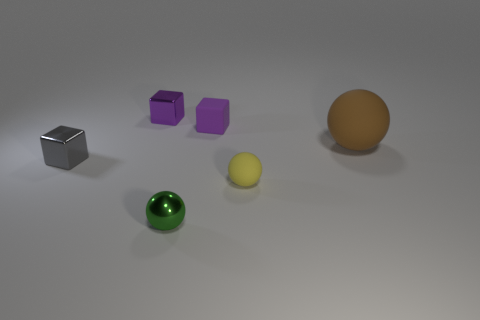Subtract all yellow blocks. Subtract all green cylinders. How many blocks are left? 3 Add 3 small green shiny objects. How many objects exist? 9 Subtract 0 purple cylinders. How many objects are left? 6 Subtract all yellow balls. Subtract all tiny gray shiny cubes. How many objects are left? 4 Add 4 small rubber blocks. How many small rubber blocks are left? 5 Add 6 tiny yellow objects. How many tiny yellow objects exist? 7 